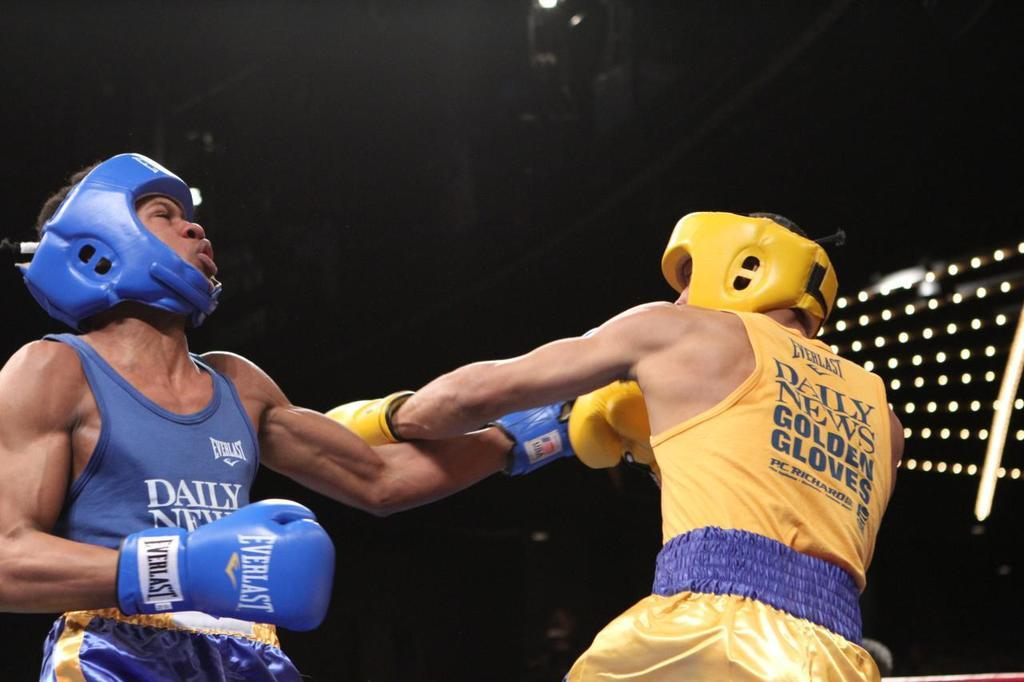<image>
Give a short and clear explanation of the subsequent image. Person wearing a blue glove that says Everlast on it. 